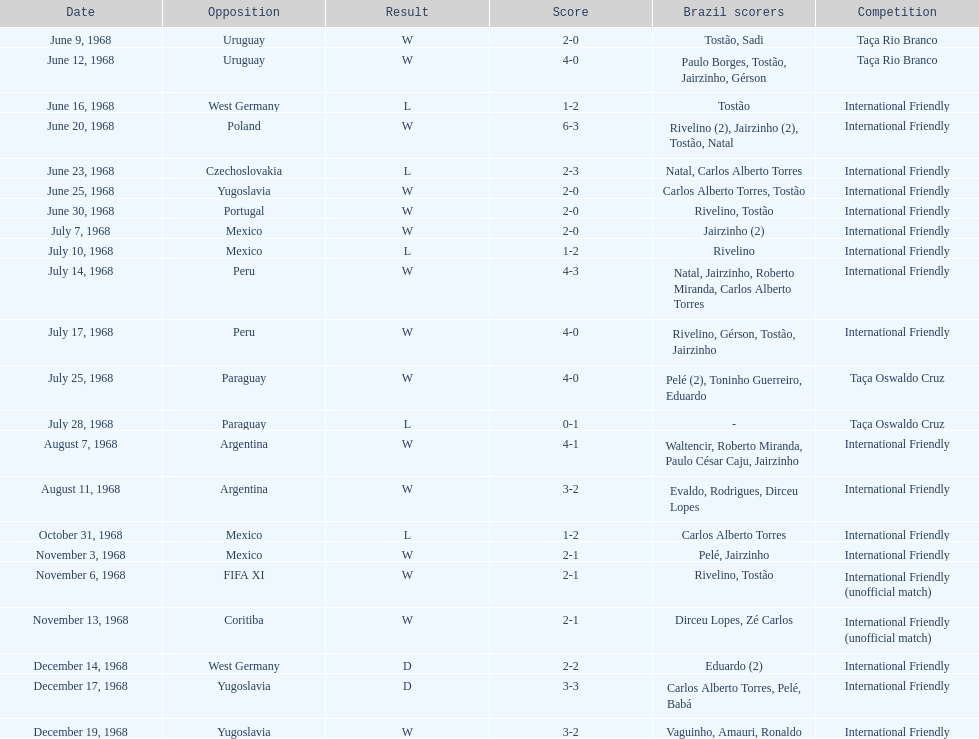What's the record for the most goals scored by brazil during one match? 6. 